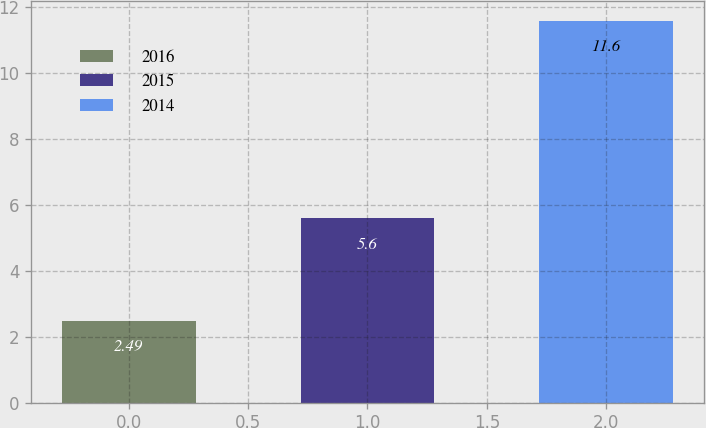Convert chart to OTSL. <chart><loc_0><loc_0><loc_500><loc_500><bar_chart><fcel>2016<fcel>2015<fcel>2014<nl><fcel>2.49<fcel>5.6<fcel>11.6<nl></chart> 